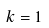<formula> <loc_0><loc_0><loc_500><loc_500>k = 1</formula> 